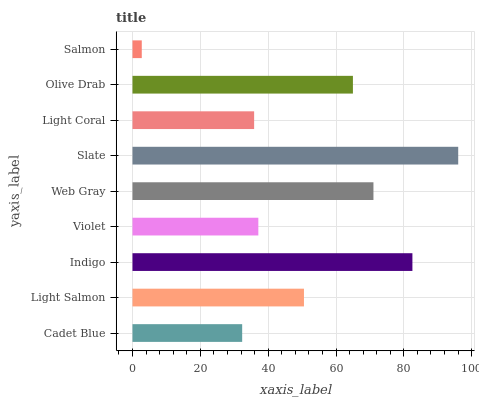Is Salmon the minimum?
Answer yes or no. Yes. Is Slate the maximum?
Answer yes or no. Yes. Is Light Salmon the minimum?
Answer yes or no. No. Is Light Salmon the maximum?
Answer yes or no. No. Is Light Salmon greater than Cadet Blue?
Answer yes or no. Yes. Is Cadet Blue less than Light Salmon?
Answer yes or no. Yes. Is Cadet Blue greater than Light Salmon?
Answer yes or no. No. Is Light Salmon less than Cadet Blue?
Answer yes or no. No. Is Light Salmon the high median?
Answer yes or no. Yes. Is Light Salmon the low median?
Answer yes or no. Yes. Is Salmon the high median?
Answer yes or no. No. Is Web Gray the low median?
Answer yes or no. No. 